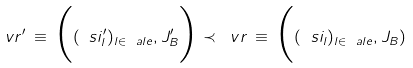<formula> <loc_0><loc_0><loc_500><loc_500>\ v r ^ { \prime } \, \equiv \, \Big ( ( \ s i _ { l } ^ { \prime } ) _ { l \in \ a l e } , J _ { B } ^ { \prime } \Big ) \prec \ v r \, \equiv \, \Big ( ( \ s i _ { l } ) _ { l \in \ a l e } , J _ { B } )</formula> 